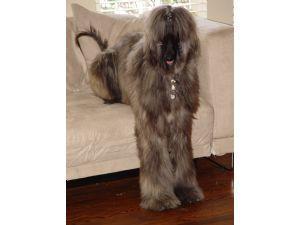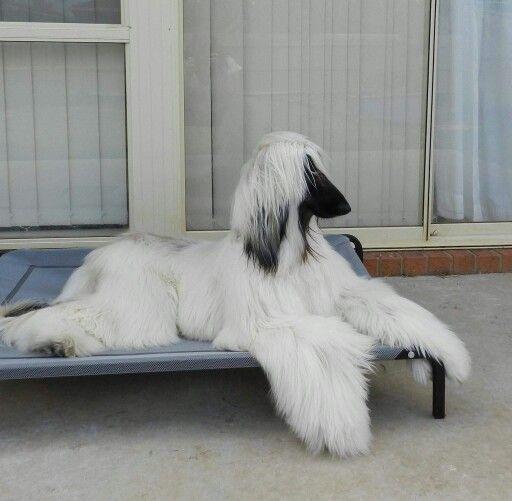The first image is the image on the left, the second image is the image on the right. Assess this claim about the two images: "At least one afghan hound with a curled upright tail is standing in profile.". Correct or not? Answer yes or no. No. The first image is the image on the left, the second image is the image on the right. Considering the images on both sides, is "At least one of the dogs is standing up outside in the grass." valid? Answer yes or no. No. 